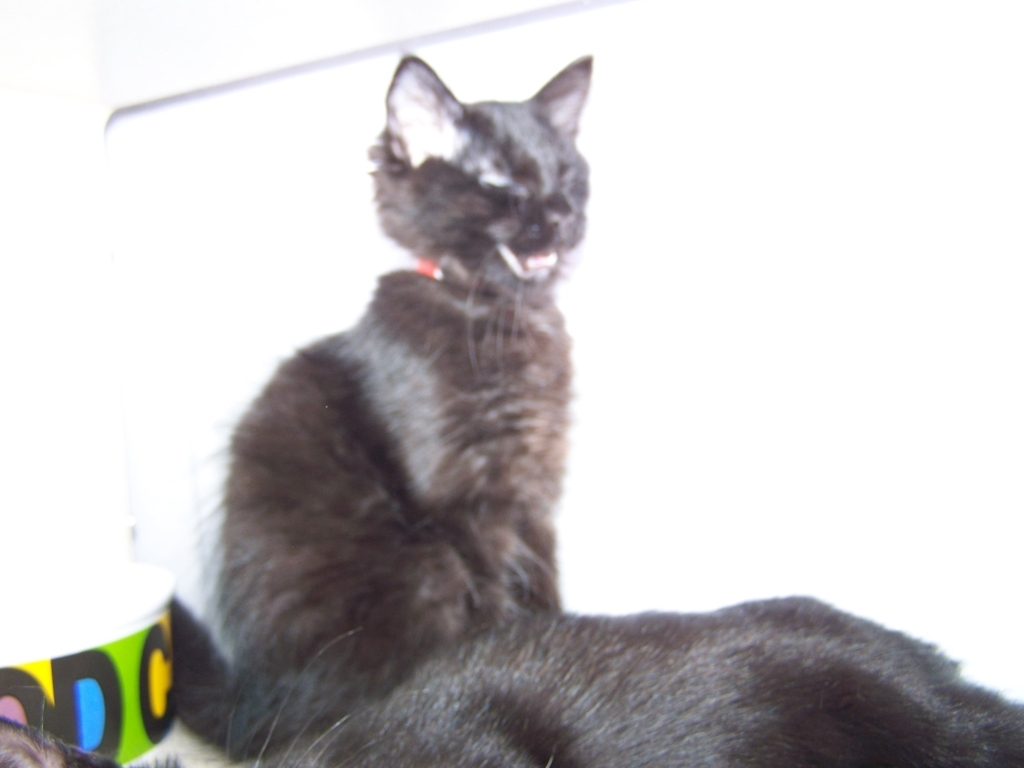Could you describe the cat's surroundings? The cat appears to be indoors, with a partial view of a colorful, patterned object nearby, likely a piece of furniture or a toy. The overall surroundings cannot be determined with precision due to the limited visible background and overexposed lighting. 